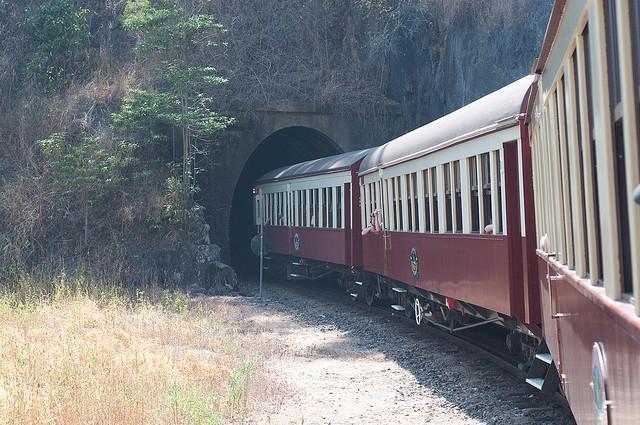How many elephants are standing on two legs?
Give a very brief answer. 0. 